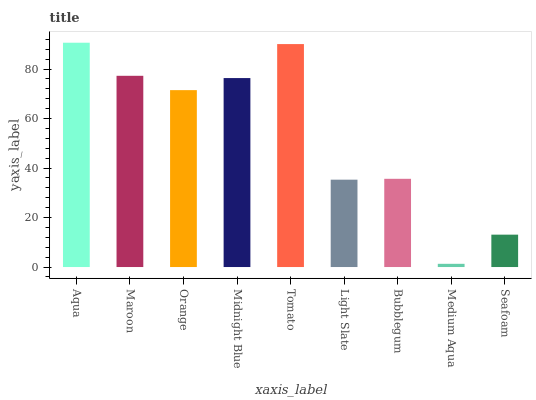Is Medium Aqua the minimum?
Answer yes or no. Yes. Is Aqua the maximum?
Answer yes or no. Yes. Is Maroon the minimum?
Answer yes or no. No. Is Maroon the maximum?
Answer yes or no. No. Is Aqua greater than Maroon?
Answer yes or no. Yes. Is Maroon less than Aqua?
Answer yes or no. Yes. Is Maroon greater than Aqua?
Answer yes or no. No. Is Aqua less than Maroon?
Answer yes or no. No. Is Orange the high median?
Answer yes or no. Yes. Is Orange the low median?
Answer yes or no. Yes. Is Aqua the high median?
Answer yes or no. No. Is Medium Aqua the low median?
Answer yes or no. No. 